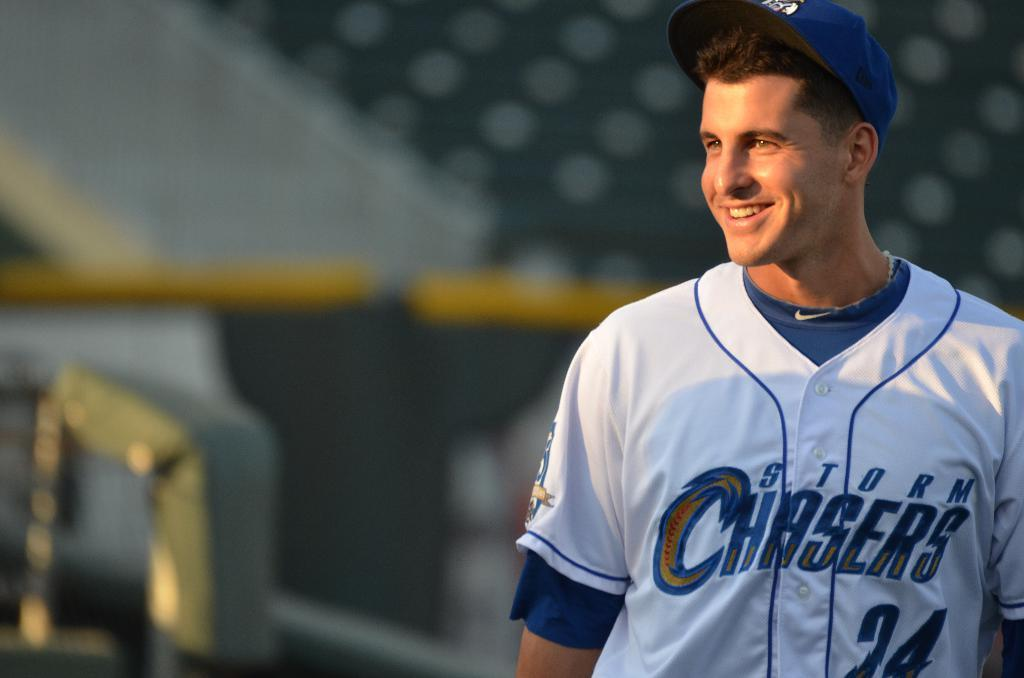<image>
Relay a brief, clear account of the picture shown. A baseball player wearing a Storm Chasers jersey smiles on the field 